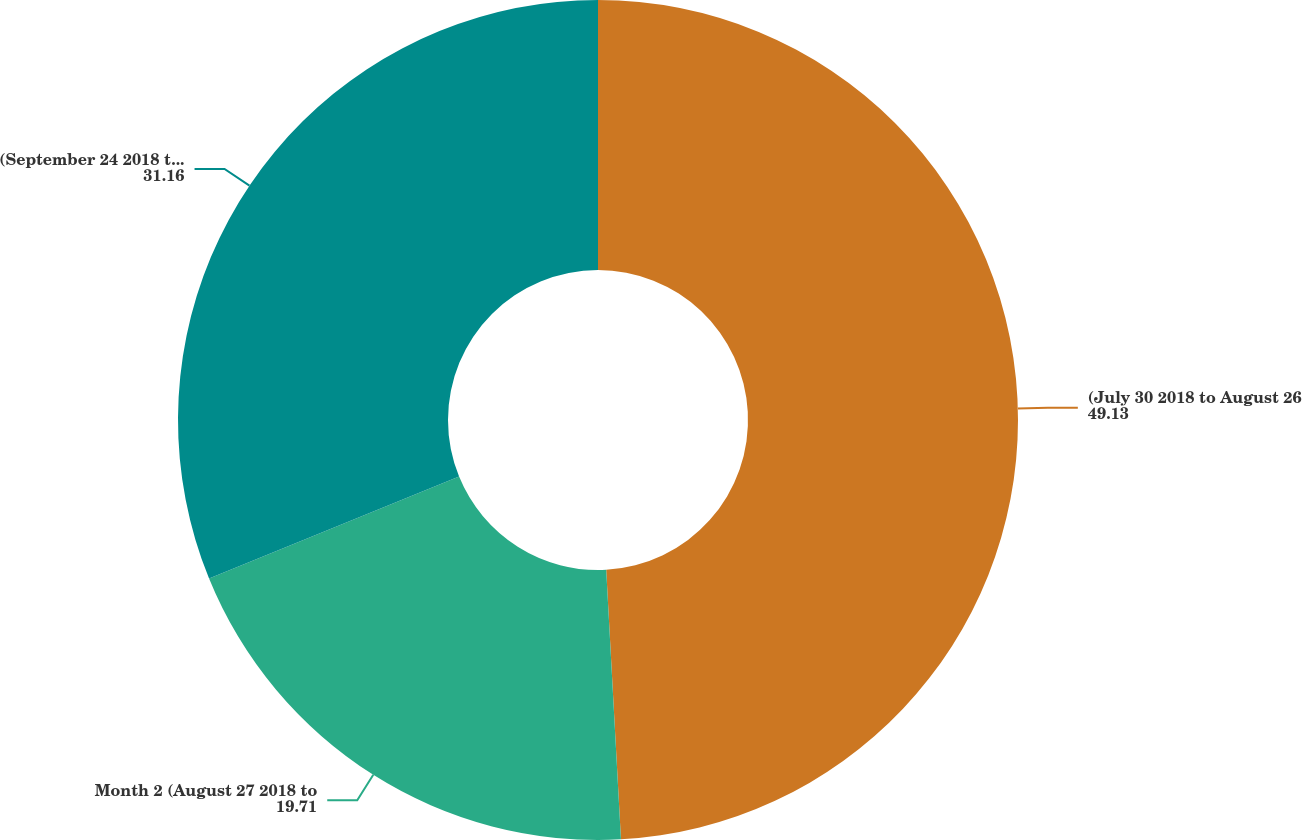Convert chart to OTSL. <chart><loc_0><loc_0><loc_500><loc_500><pie_chart><fcel>(July 30 2018 to August 26<fcel>Month 2 (August 27 2018 to<fcel>(September 24 2018 to October<nl><fcel>49.13%<fcel>19.71%<fcel>31.16%<nl></chart> 